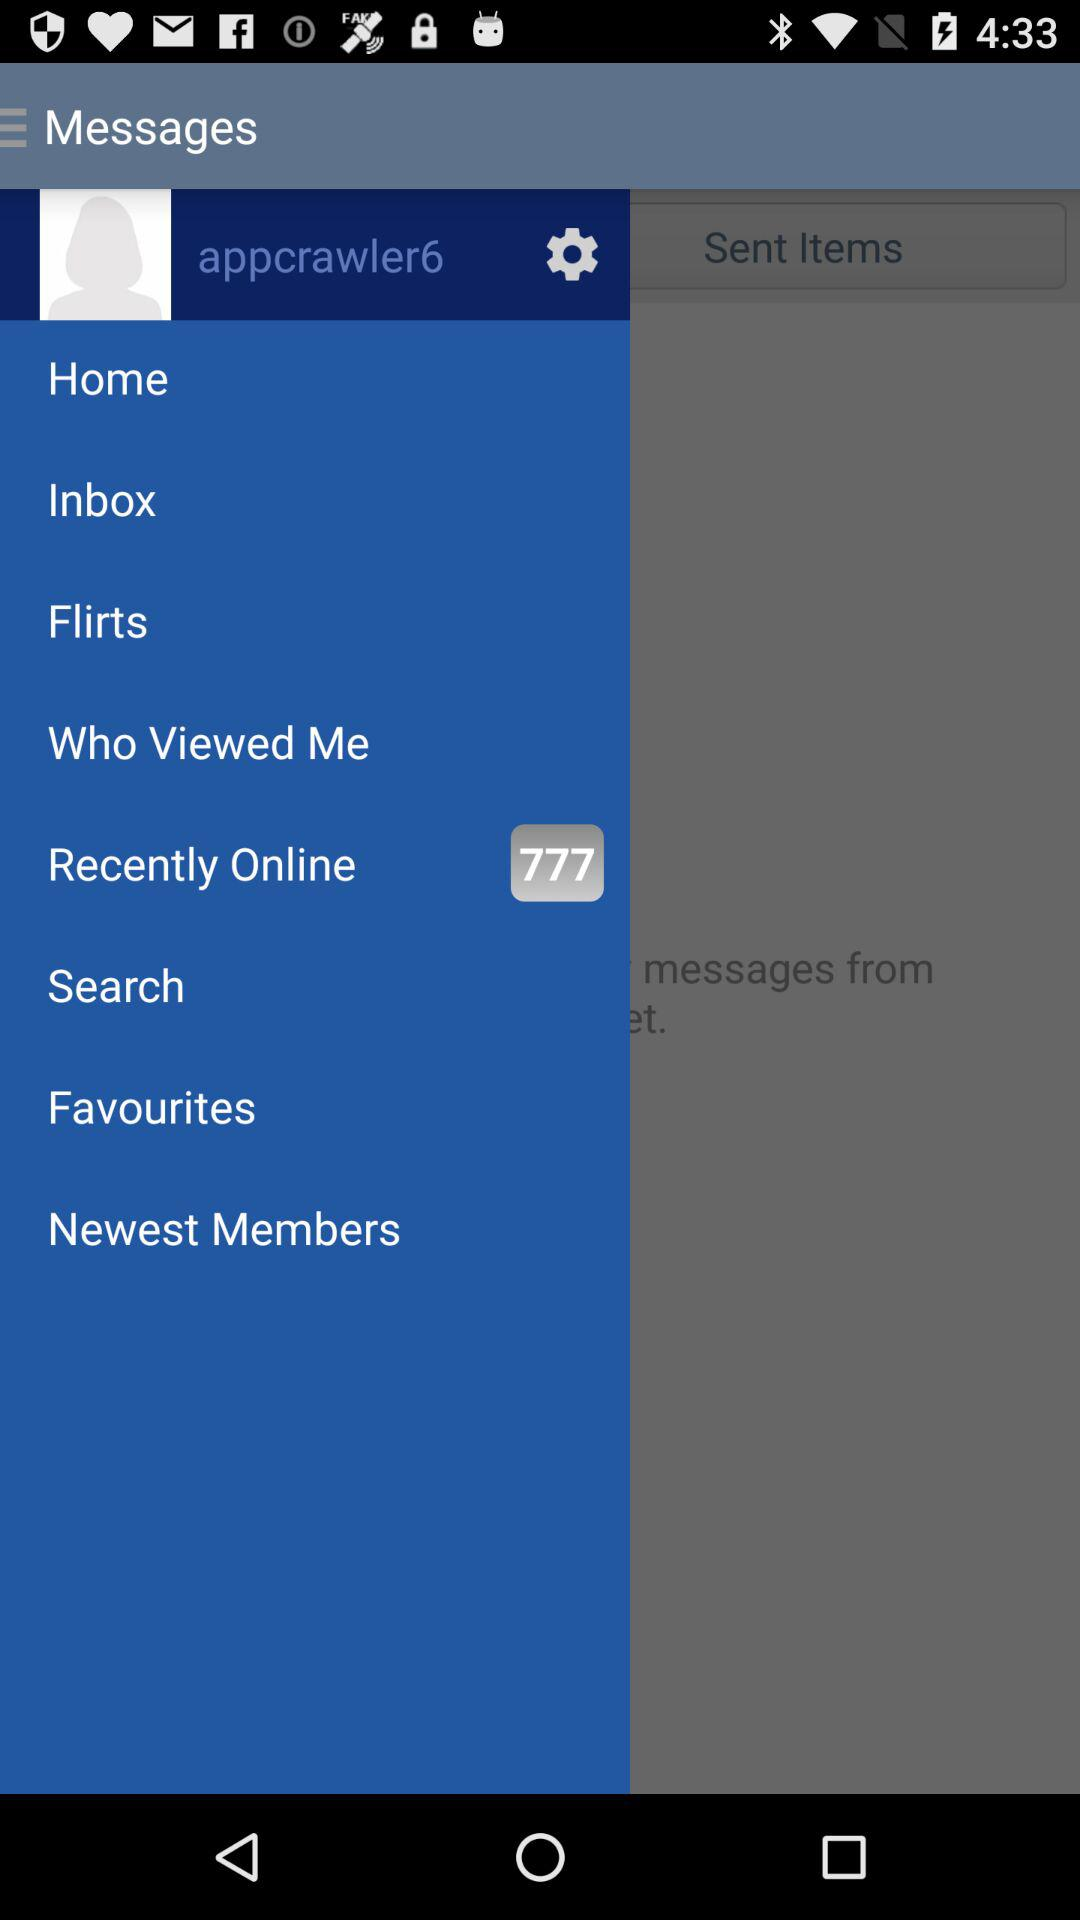How many people have recently been online? There are 777 people who have recently been online. 